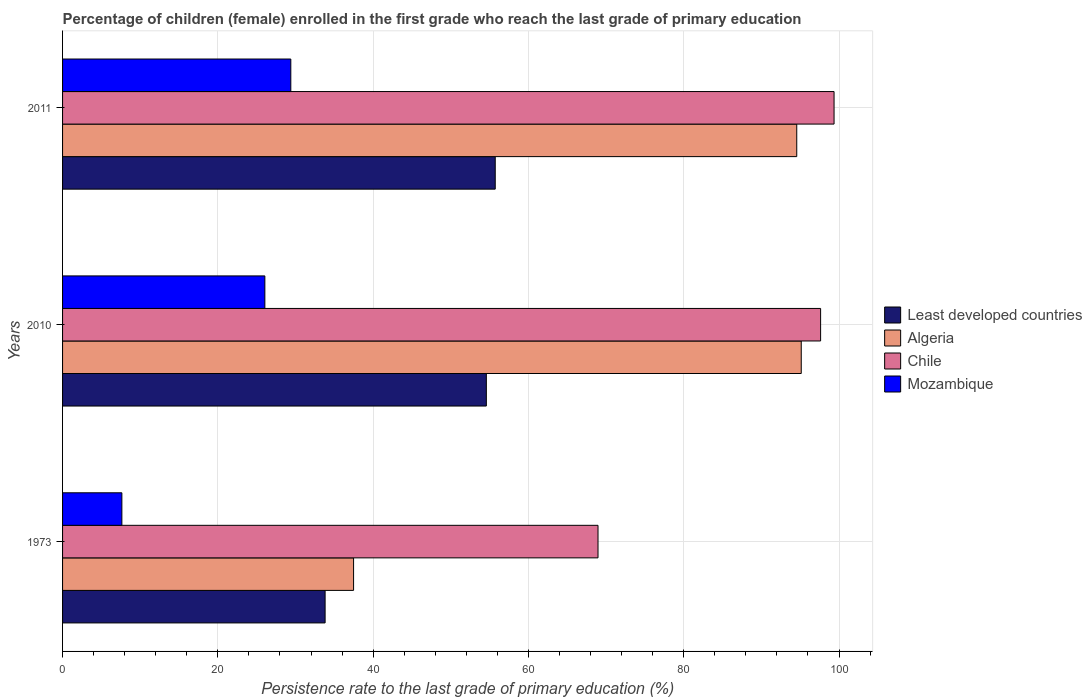How many different coloured bars are there?
Provide a short and direct response. 4. How many groups of bars are there?
Give a very brief answer. 3. How many bars are there on the 3rd tick from the top?
Ensure brevity in your answer.  4. How many bars are there on the 2nd tick from the bottom?
Provide a succinct answer. 4. In how many cases, is the number of bars for a given year not equal to the number of legend labels?
Give a very brief answer. 0. What is the persistence rate of children in Algeria in 2011?
Your response must be concise. 94.55. Across all years, what is the maximum persistence rate of children in Least developed countries?
Offer a very short reply. 55.72. Across all years, what is the minimum persistence rate of children in Chile?
Your response must be concise. 68.96. In which year was the persistence rate of children in Least developed countries maximum?
Provide a short and direct response. 2011. What is the total persistence rate of children in Algeria in the graph?
Give a very brief answer. 227.16. What is the difference between the persistence rate of children in Mozambique in 2010 and that in 2011?
Provide a succinct answer. -3.34. What is the difference between the persistence rate of children in Mozambique in 2010 and the persistence rate of children in Least developed countries in 2011?
Give a very brief answer. -29.67. What is the average persistence rate of children in Least developed countries per year?
Keep it short and to the point. 48.04. In the year 2010, what is the difference between the persistence rate of children in Algeria and persistence rate of children in Mozambique?
Your answer should be compact. 69.08. What is the ratio of the persistence rate of children in Algeria in 2010 to that in 2011?
Your answer should be compact. 1.01. Is the persistence rate of children in Mozambique in 2010 less than that in 2011?
Offer a terse response. Yes. Is the difference between the persistence rate of children in Algeria in 1973 and 2010 greater than the difference between the persistence rate of children in Mozambique in 1973 and 2010?
Offer a very short reply. No. What is the difference between the highest and the second highest persistence rate of children in Chile?
Give a very brief answer. 1.73. What is the difference between the highest and the lowest persistence rate of children in Chile?
Give a very brief answer. 30.4. In how many years, is the persistence rate of children in Least developed countries greater than the average persistence rate of children in Least developed countries taken over all years?
Give a very brief answer. 2. Is the sum of the persistence rate of children in Algeria in 1973 and 2011 greater than the maximum persistence rate of children in Least developed countries across all years?
Your answer should be very brief. Yes. What does the 3rd bar from the top in 1973 represents?
Offer a very short reply. Algeria. What does the 2nd bar from the bottom in 2010 represents?
Your answer should be very brief. Algeria. Is it the case that in every year, the sum of the persistence rate of children in Mozambique and persistence rate of children in Least developed countries is greater than the persistence rate of children in Algeria?
Keep it short and to the point. No. How many bars are there?
Your answer should be compact. 12. What is the difference between two consecutive major ticks on the X-axis?
Your answer should be very brief. 20. Are the values on the major ticks of X-axis written in scientific E-notation?
Your response must be concise. No. What is the title of the graph?
Give a very brief answer. Percentage of children (female) enrolled in the first grade who reach the last grade of primary education. Does "Chad" appear as one of the legend labels in the graph?
Give a very brief answer. No. What is the label or title of the X-axis?
Your response must be concise. Persistence rate to the last grade of primary education (%). What is the Persistence rate to the last grade of primary education (%) of Least developed countries in 1973?
Your answer should be compact. 33.81. What is the Persistence rate to the last grade of primary education (%) in Algeria in 1973?
Offer a terse response. 37.48. What is the Persistence rate to the last grade of primary education (%) of Chile in 1973?
Offer a terse response. 68.96. What is the Persistence rate to the last grade of primary education (%) of Mozambique in 1973?
Make the answer very short. 7.64. What is the Persistence rate to the last grade of primary education (%) of Least developed countries in 2010?
Give a very brief answer. 54.58. What is the Persistence rate to the last grade of primary education (%) in Algeria in 2010?
Your response must be concise. 95.13. What is the Persistence rate to the last grade of primary education (%) of Chile in 2010?
Offer a very short reply. 97.63. What is the Persistence rate to the last grade of primary education (%) of Mozambique in 2010?
Give a very brief answer. 26.05. What is the Persistence rate to the last grade of primary education (%) in Least developed countries in 2011?
Offer a terse response. 55.72. What is the Persistence rate to the last grade of primary education (%) in Algeria in 2011?
Provide a short and direct response. 94.55. What is the Persistence rate to the last grade of primary education (%) of Chile in 2011?
Provide a short and direct response. 99.36. What is the Persistence rate to the last grade of primary education (%) of Mozambique in 2011?
Offer a terse response. 29.39. Across all years, what is the maximum Persistence rate to the last grade of primary education (%) in Least developed countries?
Offer a terse response. 55.72. Across all years, what is the maximum Persistence rate to the last grade of primary education (%) in Algeria?
Provide a short and direct response. 95.13. Across all years, what is the maximum Persistence rate to the last grade of primary education (%) in Chile?
Provide a succinct answer. 99.36. Across all years, what is the maximum Persistence rate to the last grade of primary education (%) of Mozambique?
Your answer should be very brief. 29.39. Across all years, what is the minimum Persistence rate to the last grade of primary education (%) of Least developed countries?
Your answer should be very brief. 33.81. Across all years, what is the minimum Persistence rate to the last grade of primary education (%) in Algeria?
Your answer should be compact. 37.48. Across all years, what is the minimum Persistence rate to the last grade of primary education (%) of Chile?
Your answer should be compact. 68.96. Across all years, what is the minimum Persistence rate to the last grade of primary education (%) of Mozambique?
Your answer should be compact. 7.64. What is the total Persistence rate to the last grade of primary education (%) in Least developed countries in the graph?
Provide a succinct answer. 144.11. What is the total Persistence rate to the last grade of primary education (%) in Algeria in the graph?
Ensure brevity in your answer.  227.16. What is the total Persistence rate to the last grade of primary education (%) in Chile in the graph?
Your response must be concise. 265.94. What is the total Persistence rate to the last grade of primary education (%) in Mozambique in the graph?
Provide a short and direct response. 63.09. What is the difference between the Persistence rate to the last grade of primary education (%) of Least developed countries in 1973 and that in 2010?
Your response must be concise. -20.76. What is the difference between the Persistence rate to the last grade of primary education (%) of Algeria in 1973 and that in 2010?
Give a very brief answer. -57.65. What is the difference between the Persistence rate to the last grade of primary education (%) in Chile in 1973 and that in 2010?
Your answer should be compact. -28.67. What is the difference between the Persistence rate to the last grade of primary education (%) of Mozambique in 1973 and that in 2010?
Your answer should be compact. -18.42. What is the difference between the Persistence rate to the last grade of primary education (%) in Least developed countries in 1973 and that in 2011?
Make the answer very short. -21.91. What is the difference between the Persistence rate to the last grade of primary education (%) in Algeria in 1973 and that in 2011?
Offer a very short reply. -57.07. What is the difference between the Persistence rate to the last grade of primary education (%) of Chile in 1973 and that in 2011?
Keep it short and to the point. -30.4. What is the difference between the Persistence rate to the last grade of primary education (%) in Mozambique in 1973 and that in 2011?
Ensure brevity in your answer.  -21.76. What is the difference between the Persistence rate to the last grade of primary education (%) in Least developed countries in 2010 and that in 2011?
Provide a short and direct response. -1.14. What is the difference between the Persistence rate to the last grade of primary education (%) in Algeria in 2010 and that in 2011?
Provide a succinct answer. 0.58. What is the difference between the Persistence rate to the last grade of primary education (%) of Chile in 2010 and that in 2011?
Provide a short and direct response. -1.73. What is the difference between the Persistence rate to the last grade of primary education (%) of Mozambique in 2010 and that in 2011?
Give a very brief answer. -3.34. What is the difference between the Persistence rate to the last grade of primary education (%) of Least developed countries in 1973 and the Persistence rate to the last grade of primary education (%) of Algeria in 2010?
Keep it short and to the point. -61.32. What is the difference between the Persistence rate to the last grade of primary education (%) of Least developed countries in 1973 and the Persistence rate to the last grade of primary education (%) of Chile in 2010?
Offer a very short reply. -63.81. What is the difference between the Persistence rate to the last grade of primary education (%) of Least developed countries in 1973 and the Persistence rate to the last grade of primary education (%) of Mozambique in 2010?
Provide a succinct answer. 7.76. What is the difference between the Persistence rate to the last grade of primary education (%) of Algeria in 1973 and the Persistence rate to the last grade of primary education (%) of Chile in 2010?
Your answer should be very brief. -60.15. What is the difference between the Persistence rate to the last grade of primary education (%) in Algeria in 1973 and the Persistence rate to the last grade of primary education (%) in Mozambique in 2010?
Keep it short and to the point. 11.43. What is the difference between the Persistence rate to the last grade of primary education (%) of Chile in 1973 and the Persistence rate to the last grade of primary education (%) of Mozambique in 2010?
Provide a short and direct response. 42.91. What is the difference between the Persistence rate to the last grade of primary education (%) in Least developed countries in 1973 and the Persistence rate to the last grade of primary education (%) in Algeria in 2011?
Your answer should be very brief. -60.74. What is the difference between the Persistence rate to the last grade of primary education (%) in Least developed countries in 1973 and the Persistence rate to the last grade of primary education (%) in Chile in 2011?
Provide a succinct answer. -65.55. What is the difference between the Persistence rate to the last grade of primary education (%) in Least developed countries in 1973 and the Persistence rate to the last grade of primary education (%) in Mozambique in 2011?
Your response must be concise. 4.42. What is the difference between the Persistence rate to the last grade of primary education (%) in Algeria in 1973 and the Persistence rate to the last grade of primary education (%) in Chile in 2011?
Make the answer very short. -61.88. What is the difference between the Persistence rate to the last grade of primary education (%) in Algeria in 1973 and the Persistence rate to the last grade of primary education (%) in Mozambique in 2011?
Offer a terse response. 8.08. What is the difference between the Persistence rate to the last grade of primary education (%) of Chile in 1973 and the Persistence rate to the last grade of primary education (%) of Mozambique in 2011?
Give a very brief answer. 39.56. What is the difference between the Persistence rate to the last grade of primary education (%) of Least developed countries in 2010 and the Persistence rate to the last grade of primary education (%) of Algeria in 2011?
Your response must be concise. -39.97. What is the difference between the Persistence rate to the last grade of primary education (%) of Least developed countries in 2010 and the Persistence rate to the last grade of primary education (%) of Chile in 2011?
Keep it short and to the point. -44.78. What is the difference between the Persistence rate to the last grade of primary education (%) of Least developed countries in 2010 and the Persistence rate to the last grade of primary education (%) of Mozambique in 2011?
Your response must be concise. 25.18. What is the difference between the Persistence rate to the last grade of primary education (%) in Algeria in 2010 and the Persistence rate to the last grade of primary education (%) in Chile in 2011?
Your answer should be very brief. -4.23. What is the difference between the Persistence rate to the last grade of primary education (%) of Algeria in 2010 and the Persistence rate to the last grade of primary education (%) of Mozambique in 2011?
Make the answer very short. 65.74. What is the difference between the Persistence rate to the last grade of primary education (%) of Chile in 2010 and the Persistence rate to the last grade of primary education (%) of Mozambique in 2011?
Keep it short and to the point. 68.23. What is the average Persistence rate to the last grade of primary education (%) in Least developed countries per year?
Your answer should be compact. 48.04. What is the average Persistence rate to the last grade of primary education (%) of Algeria per year?
Offer a terse response. 75.72. What is the average Persistence rate to the last grade of primary education (%) in Chile per year?
Make the answer very short. 88.65. What is the average Persistence rate to the last grade of primary education (%) of Mozambique per year?
Make the answer very short. 21.03. In the year 1973, what is the difference between the Persistence rate to the last grade of primary education (%) of Least developed countries and Persistence rate to the last grade of primary education (%) of Algeria?
Provide a short and direct response. -3.67. In the year 1973, what is the difference between the Persistence rate to the last grade of primary education (%) of Least developed countries and Persistence rate to the last grade of primary education (%) of Chile?
Give a very brief answer. -35.15. In the year 1973, what is the difference between the Persistence rate to the last grade of primary education (%) in Least developed countries and Persistence rate to the last grade of primary education (%) in Mozambique?
Your answer should be very brief. 26.17. In the year 1973, what is the difference between the Persistence rate to the last grade of primary education (%) in Algeria and Persistence rate to the last grade of primary education (%) in Chile?
Your response must be concise. -31.48. In the year 1973, what is the difference between the Persistence rate to the last grade of primary education (%) of Algeria and Persistence rate to the last grade of primary education (%) of Mozambique?
Your answer should be very brief. 29.84. In the year 1973, what is the difference between the Persistence rate to the last grade of primary education (%) of Chile and Persistence rate to the last grade of primary education (%) of Mozambique?
Keep it short and to the point. 61.32. In the year 2010, what is the difference between the Persistence rate to the last grade of primary education (%) of Least developed countries and Persistence rate to the last grade of primary education (%) of Algeria?
Offer a terse response. -40.55. In the year 2010, what is the difference between the Persistence rate to the last grade of primary education (%) in Least developed countries and Persistence rate to the last grade of primary education (%) in Chile?
Provide a short and direct response. -43.05. In the year 2010, what is the difference between the Persistence rate to the last grade of primary education (%) of Least developed countries and Persistence rate to the last grade of primary education (%) of Mozambique?
Offer a very short reply. 28.52. In the year 2010, what is the difference between the Persistence rate to the last grade of primary education (%) of Algeria and Persistence rate to the last grade of primary education (%) of Chile?
Your answer should be very brief. -2.49. In the year 2010, what is the difference between the Persistence rate to the last grade of primary education (%) of Algeria and Persistence rate to the last grade of primary education (%) of Mozambique?
Offer a terse response. 69.08. In the year 2010, what is the difference between the Persistence rate to the last grade of primary education (%) in Chile and Persistence rate to the last grade of primary education (%) in Mozambique?
Give a very brief answer. 71.57. In the year 2011, what is the difference between the Persistence rate to the last grade of primary education (%) of Least developed countries and Persistence rate to the last grade of primary education (%) of Algeria?
Your answer should be very brief. -38.83. In the year 2011, what is the difference between the Persistence rate to the last grade of primary education (%) in Least developed countries and Persistence rate to the last grade of primary education (%) in Chile?
Provide a short and direct response. -43.64. In the year 2011, what is the difference between the Persistence rate to the last grade of primary education (%) of Least developed countries and Persistence rate to the last grade of primary education (%) of Mozambique?
Ensure brevity in your answer.  26.33. In the year 2011, what is the difference between the Persistence rate to the last grade of primary education (%) of Algeria and Persistence rate to the last grade of primary education (%) of Chile?
Offer a very short reply. -4.81. In the year 2011, what is the difference between the Persistence rate to the last grade of primary education (%) of Algeria and Persistence rate to the last grade of primary education (%) of Mozambique?
Provide a short and direct response. 65.16. In the year 2011, what is the difference between the Persistence rate to the last grade of primary education (%) in Chile and Persistence rate to the last grade of primary education (%) in Mozambique?
Ensure brevity in your answer.  69.96. What is the ratio of the Persistence rate to the last grade of primary education (%) in Least developed countries in 1973 to that in 2010?
Make the answer very short. 0.62. What is the ratio of the Persistence rate to the last grade of primary education (%) in Algeria in 1973 to that in 2010?
Provide a succinct answer. 0.39. What is the ratio of the Persistence rate to the last grade of primary education (%) of Chile in 1973 to that in 2010?
Ensure brevity in your answer.  0.71. What is the ratio of the Persistence rate to the last grade of primary education (%) of Mozambique in 1973 to that in 2010?
Provide a short and direct response. 0.29. What is the ratio of the Persistence rate to the last grade of primary education (%) of Least developed countries in 1973 to that in 2011?
Provide a short and direct response. 0.61. What is the ratio of the Persistence rate to the last grade of primary education (%) of Algeria in 1973 to that in 2011?
Offer a terse response. 0.4. What is the ratio of the Persistence rate to the last grade of primary education (%) of Chile in 1973 to that in 2011?
Offer a very short reply. 0.69. What is the ratio of the Persistence rate to the last grade of primary education (%) in Mozambique in 1973 to that in 2011?
Keep it short and to the point. 0.26. What is the ratio of the Persistence rate to the last grade of primary education (%) of Least developed countries in 2010 to that in 2011?
Offer a very short reply. 0.98. What is the ratio of the Persistence rate to the last grade of primary education (%) in Algeria in 2010 to that in 2011?
Offer a very short reply. 1.01. What is the ratio of the Persistence rate to the last grade of primary education (%) of Chile in 2010 to that in 2011?
Provide a succinct answer. 0.98. What is the ratio of the Persistence rate to the last grade of primary education (%) of Mozambique in 2010 to that in 2011?
Give a very brief answer. 0.89. What is the difference between the highest and the second highest Persistence rate to the last grade of primary education (%) in Least developed countries?
Offer a terse response. 1.14. What is the difference between the highest and the second highest Persistence rate to the last grade of primary education (%) of Algeria?
Keep it short and to the point. 0.58. What is the difference between the highest and the second highest Persistence rate to the last grade of primary education (%) in Chile?
Your answer should be very brief. 1.73. What is the difference between the highest and the second highest Persistence rate to the last grade of primary education (%) in Mozambique?
Offer a very short reply. 3.34. What is the difference between the highest and the lowest Persistence rate to the last grade of primary education (%) of Least developed countries?
Offer a terse response. 21.91. What is the difference between the highest and the lowest Persistence rate to the last grade of primary education (%) of Algeria?
Keep it short and to the point. 57.65. What is the difference between the highest and the lowest Persistence rate to the last grade of primary education (%) of Chile?
Your response must be concise. 30.4. What is the difference between the highest and the lowest Persistence rate to the last grade of primary education (%) in Mozambique?
Ensure brevity in your answer.  21.76. 